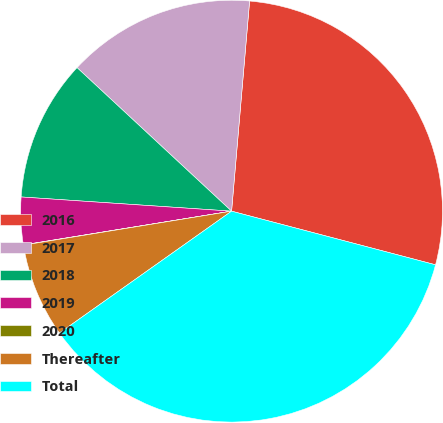Convert chart. <chart><loc_0><loc_0><loc_500><loc_500><pie_chart><fcel>2016<fcel>2017<fcel>2018<fcel>2019<fcel>2020<fcel>Thereafter<fcel>Total<nl><fcel>27.73%<fcel>14.45%<fcel>10.84%<fcel>3.63%<fcel>0.02%<fcel>7.23%<fcel>36.1%<nl></chart> 